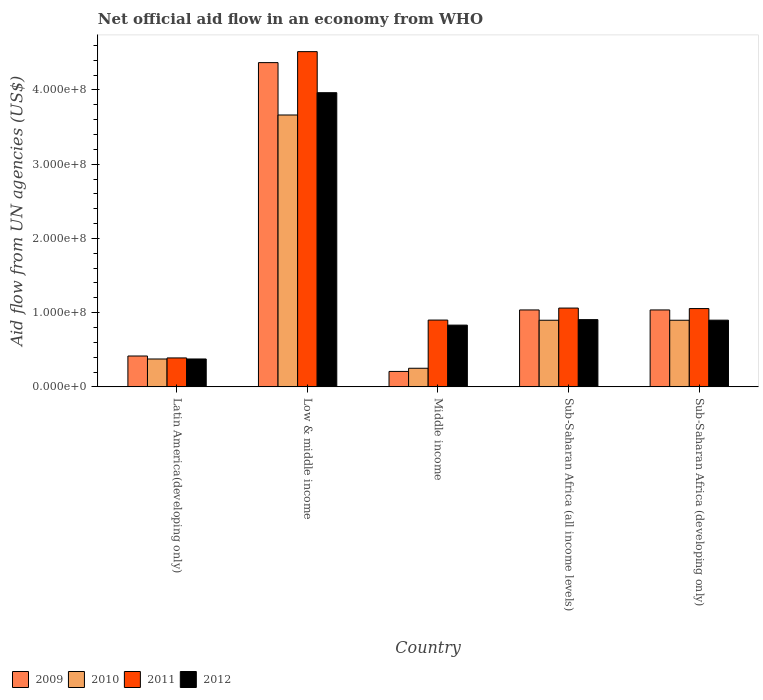How many different coloured bars are there?
Offer a terse response. 4. Are the number of bars per tick equal to the number of legend labels?
Make the answer very short. Yes. What is the label of the 5th group of bars from the left?
Give a very brief answer. Sub-Saharan Africa (developing only). What is the net official aid flow in 2009 in Middle income?
Your answer should be compact. 2.08e+07. Across all countries, what is the maximum net official aid flow in 2011?
Offer a terse response. 4.52e+08. Across all countries, what is the minimum net official aid flow in 2010?
Make the answer very short. 2.51e+07. In which country was the net official aid flow in 2011 maximum?
Give a very brief answer. Low & middle income. In which country was the net official aid flow in 2012 minimum?
Provide a succinct answer. Latin America(developing only). What is the total net official aid flow in 2010 in the graph?
Ensure brevity in your answer.  6.08e+08. What is the difference between the net official aid flow in 2012 in Latin America(developing only) and that in Low & middle income?
Provide a succinct answer. -3.59e+08. What is the difference between the net official aid flow in 2010 in Sub-Saharan Africa (developing only) and the net official aid flow in 2009 in Latin America(developing only)?
Your answer should be compact. 4.82e+07. What is the average net official aid flow in 2010 per country?
Make the answer very short. 1.22e+08. What is the difference between the net official aid flow of/in 2012 and net official aid flow of/in 2009 in Sub-Saharan Africa (developing only)?
Your response must be concise. -1.38e+07. In how many countries, is the net official aid flow in 2010 greater than 80000000 US$?
Your response must be concise. 3. What is the ratio of the net official aid flow in 2011 in Low & middle income to that in Sub-Saharan Africa (all income levels)?
Offer a very short reply. 4.25. Is the net official aid flow in 2012 in Latin America(developing only) less than that in Low & middle income?
Provide a short and direct response. Yes. Is the difference between the net official aid flow in 2012 in Latin America(developing only) and Low & middle income greater than the difference between the net official aid flow in 2009 in Latin America(developing only) and Low & middle income?
Ensure brevity in your answer.  Yes. What is the difference between the highest and the second highest net official aid flow in 2009?
Offer a terse response. 3.33e+08. What is the difference between the highest and the lowest net official aid flow in 2012?
Your response must be concise. 3.59e+08. Is it the case that in every country, the sum of the net official aid flow in 2011 and net official aid flow in 2012 is greater than the sum of net official aid flow in 2010 and net official aid flow in 2009?
Ensure brevity in your answer.  No. What does the 2nd bar from the left in Latin America(developing only) represents?
Your answer should be compact. 2010. Is it the case that in every country, the sum of the net official aid flow in 2010 and net official aid flow in 2011 is greater than the net official aid flow in 2009?
Offer a terse response. Yes. How many countries are there in the graph?
Provide a short and direct response. 5. Does the graph contain any zero values?
Provide a short and direct response. No. Does the graph contain grids?
Offer a very short reply. No. What is the title of the graph?
Give a very brief answer. Net official aid flow in an economy from WHO. Does "1988" appear as one of the legend labels in the graph?
Give a very brief answer. No. What is the label or title of the Y-axis?
Your answer should be compact. Aid flow from UN agencies (US$). What is the Aid flow from UN agencies (US$) of 2009 in Latin America(developing only)?
Provide a short and direct response. 4.16e+07. What is the Aid flow from UN agencies (US$) of 2010 in Latin America(developing only)?
Provide a short and direct response. 3.76e+07. What is the Aid flow from UN agencies (US$) of 2011 in Latin America(developing only)?
Your answer should be very brief. 3.90e+07. What is the Aid flow from UN agencies (US$) of 2012 in Latin America(developing only)?
Offer a terse response. 3.76e+07. What is the Aid flow from UN agencies (US$) of 2009 in Low & middle income?
Your answer should be compact. 4.37e+08. What is the Aid flow from UN agencies (US$) in 2010 in Low & middle income?
Offer a very short reply. 3.66e+08. What is the Aid flow from UN agencies (US$) in 2011 in Low & middle income?
Your response must be concise. 4.52e+08. What is the Aid flow from UN agencies (US$) of 2012 in Low & middle income?
Make the answer very short. 3.96e+08. What is the Aid flow from UN agencies (US$) in 2009 in Middle income?
Your answer should be very brief. 2.08e+07. What is the Aid flow from UN agencies (US$) in 2010 in Middle income?
Provide a succinct answer. 2.51e+07. What is the Aid flow from UN agencies (US$) in 2011 in Middle income?
Offer a terse response. 9.00e+07. What is the Aid flow from UN agencies (US$) in 2012 in Middle income?
Provide a short and direct response. 8.32e+07. What is the Aid flow from UN agencies (US$) of 2009 in Sub-Saharan Africa (all income levels)?
Make the answer very short. 1.04e+08. What is the Aid flow from UN agencies (US$) of 2010 in Sub-Saharan Africa (all income levels)?
Keep it short and to the point. 8.98e+07. What is the Aid flow from UN agencies (US$) of 2011 in Sub-Saharan Africa (all income levels)?
Ensure brevity in your answer.  1.06e+08. What is the Aid flow from UN agencies (US$) of 2012 in Sub-Saharan Africa (all income levels)?
Your response must be concise. 9.06e+07. What is the Aid flow from UN agencies (US$) of 2009 in Sub-Saharan Africa (developing only)?
Ensure brevity in your answer.  1.04e+08. What is the Aid flow from UN agencies (US$) in 2010 in Sub-Saharan Africa (developing only)?
Give a very brief answer. 8.98e+07. What is the Aid flow from UN agencies (US$) in 2011 in Sub-Saharan Africa (developing only)?
Give a very brief answer. 1.05e+08. What is the Aid flow from UN agencies (US$) of 2012 in Sub-Saharan Africa (developing only)?
Your response must be concise. 8.98e+07. Across all countries, what is the maximum Aid flow from UN agencies (US$) of 2009?
Make the answer very short. 4.37e+08. Across all countries, what is the maximum Aid flow from UN agencies (US$) of 2010?
Your response must be concise. 3.66e+08. Across all countries, what is the maximum Aid flow from UN agencies (US$) in 2011?
Keep it short and to the point. 4.52e+08. Across all countries, what is the maximum Aid flow from UN agencies (US$) of 2012?
Make the answer very short. 3.96e+08. Across all countries, what is the minimum Aid flow from UN agencies (US$) in 2009?
Your response must be concise. 2.08e+07. Across all countries, what is the minimum Aid flow from UN agencies (US$) of 2010?
Your answer should be very brief. 2.51e+07. Across all countries, what is the minimum Aid flow from UN agencies (US$) of 2011?
Your answer should be compact. 3.90e+07. Across all countries, what is the minimum Aid flow from UN agencies (US$) of 2012?
Your answer should be very brief. 3.76e+07. What is the total Aid flow from UN agencies (US$) in 2009 in the graph?
Provide a succinct answer. 7.06e+08. What is the total Aid flow from UN agencies (US$) in 2010 in the graph?
Your answer should be compact. 6.08e+08. What is the total Aid flow from UN agencies (US$) in 2011 in the graph?
Your answer should be very brief. 7.92e+08. What is the total Aid flow from UN agencies (US$) of 2012 in the graph?
Give a very brief answer. 6.97e+08. What is the difference between the Aid flow from UN agencies (US$) of 2009 in Latin America(developing only) and that in Low & middle income?
Provide a short and direct response. -3.95e+08. What is the difference between the Aid flow from UN agencies (US$) in 2010 in Latin America(developing only) and that in Low & middle income?
Your answer should be very brief. -3.29e+08. What is the difference between the Aid flow from UN agencies (US$) of 2011 in Latin America(developing only) and that in Low & middle income?
Make the answer very short. -4.13e+08. What is the difference between the Aid flow from UN agencies (US$) in 2012 in Latin America(developing only) and that in Low & middle income?
Give a very brief answer. -3.59e+08. What is the difference between the Aid flow from UN agencies (US$) in 2009 in Latin America(developing only) and that in Middle income?
Offer a terse response. 2.08e+07. What is the difference between the Aid flow from UN agencies (US$) in 2010 in Latin America(developing only) and that in Middle income?
Ensure brevity in your answer.  1.25e+07. What is the difference between the Aid flow from UN agencies (US$) in 2011 in Latin America(developing only) and that in Middle income?
Make the answer very short. -5.10e+07. What is the difference between the Aid flow from UN agencies (US$) of 2012 in Latin America(developing only) and that in Middle income?
Keep it short and to the point. -4.56e+07. What is the difference between the Aid flow from UN agencies (US$) in 2009 in Latin America(developing only) and that in Sub-Saharan Africa (all income levels)?
Make the answer very short. -6.20e+07. What is the difference between the Aid flow from UN agencies (US$) of 2010 in Latin America(developing only) and that in Sub-Saharan Africa (all income levels)?
Make the answer very short. -5.22e+07. What is the difference between the Aid flow from UN agencies (US$) in 2011 in Latin America(developing only) and that in Sub-Saharan Africa (all income levels)?
Provide a short and direct response. -6.72e+07. What is the difference between the Aid flow from UN agencies (US$) in 2012 in Latin America(developing only) and that in Sub-Saharan Africa (all income levels)?
Provide a succinct answer. -5.30e+07. What is the difference between the Aid flow from UN agencies (US$) in 2009 in Latin America(developing only) and that in Sub-Saharan Africa (developing only)?
Make the answer very short. -6.20e+07. What is the difference between the Aid flow from UN agencies (US$) of 2010 in Latin America(developing only) and that in Sub-Saharan Africa (developing only)?
Keep it short and to the point. -5.22e+07. What is the difference between the Aid flow from UN agencies (US$) in 2011 in Latin America(developing only) and that in Sub-Saharan Africa (developing only)?
Provide a short and direct response. -6.65e+07. What is the difference between the Aid flow from UN agencies (US$) of 2012 in Latin America(developing only) and that in Sub-Saharan Africa (developing only)?
Give a very brief answer. -5.23e+07. What is the difference between the Aid flow from UN agencies (US$) in 2009 in Low & middle income and that in Middle income?
Keep it short and to the point. 4.16e+08. What is the difference between the Aid flow from UN agencies (US$) in 2010 in Low & middle income and that in Middle income?
Offer a terse response. 3.41e+08. What is the difference between the Aid flow from UN agencies (US$) of 2011 in Low & middle income and that in Middle income?
Ensure brevity in your answer.  3.62e+08. What is the difference between the Aid flow from UN agencies (US$) of 2012 in Low & middle income and that in Middle income?
Your answer should be very brief. 3.13e+08. What is the difference between the Aid flow from UN agencies (US$) in 2009 in Low & middle income and that in Sub-Saharan Africa (all income levels)?
Make the answer very short. 3.33e+08. What is the difference between the Aid flow from UN agencies (US$) of 2010 in Low & middle income and that in Sub-Saharan Africa (all income levels)?
Keep it short and to the point. 2.76e+08. What is the difference between the Aid flow from UN agencies (US$) in 2011 in Low & middle income and that in Sub-Saharan Africa (all income levels)?
Ensure brevity in your answer.  3.45e+08. What is the difference between the Aid flow from UN agencies (US$) of 2012 in Low & middle income and that in Sub-Saharan Africa (all income levels)?
Make the answer very short. 3.06e+08. What is the difference between the Aid flow from UN agencies (US$) of 2009 in Low & middle income and that in Sub-Saharan Africa (developing only)?
Your response must be concise. 3.33e+08. What is the difference between the Aid flow from UN agencies (US$) in 2010 in Low & middle income and that in Sub-Saharan Africa (developing only)?
Ensure brevity in your answer.  2.76e+08. What is the difference between the Aid flow from UN agencies (US$) in 2011 in Low & middle income and that in Sub-Saharan Africa (developing only)?
Offer a terse response. 3.46e+08. What is the difference between the Aid flow from UN agencies (US$) of 2012 in Low & middle income and that in Sub-Saharan Africa (developing only)?
Provide a succinct answer. 3.06e+08. What is the difference between the Aid flow from UN agencies (US$) of 2009 in Middle income and that in Sub-Saharan Africa (all income levels)?
Give a very brief answer. -8.28e+07. What is the difference between the Aid flow from UN agencies (US$) in 2010 in Middle income and that in Sub-Saharan Africa (all income levels)?
Provide a succinct answer. -6.47e+07. What is the difference between the Aid flow from UN agencies (US$) of 2011 in Middle income and that in Sub-Saharan Africa (all income levels)?
Keep it short and to the point. -1.62e+07. What is the difference between the Aid flow from UN agencies (US$) in 2012 in Middle income and that in Sub-Saharan Africa (all income levels)?
Make the answer very short. -7.39e+06. What is the difference between the Aid flow from UN agencies (US$) in 2009 in Middle income and that in Sub-Saharan Africa (developing only)?
Offer a very short reply. -8.28e+07. What is the difference between the Aid flow from UN agencies (US$) of 2010 in Middle income and that in Sub-Saharan Africa (developing only)?
Your response must be concise. -6.47e+07. What is the difference between the Aid flow from UN agencies (US$) in 2011 in Middle income and that in Sub-Saharan Africa (developing only)?
Offer a terse response. -1.55e+07. What is the difference between the Aid flow from UN agencies (US$) of 2012 in Middle income and that in Sub-Saharan Africa (developing only)?
Provide a succinct answer. -6.67e+06. What is the difference between the Aid flow from UN agencies (US$) of 2011 in Sub-Saharan Africa (all income levels) and that in Sub-Saharan Africa (developing only)?
Offer a very short reply. 6.70e+05. What is the difference between the Aid flow from UN agencies (US$) of 2012 in Sub-Saharan Africa (all income levels) and that in Sub-Saharan Africa (developing only)?
Keep it short and to the point. 7.20e+05. What is the difference between the Aid flow from UN agencies (US$) in 2009 in Latin America(developing only) and the Aid flow from UN agencies (US$) in 2010 in Low & middle income?
Provide a succinct answer. -3.25e+08. What is the difference between the Aid flow from UN agencies (US$) in 2009 in Latin America(developing only) and the Aid flow from UN agencies (US$) in 2011 in Low & middle income?
Ensure brevity in your answer.  -4.10e+08. What is the difference between the Aid flow from UN agencies (US$) of 2009 in Latin America(developing only) and the Aid flow from UN agencies (US$) of 2012 in Low & middle income?
Offer a terse response. -3.55e+08. What is the difference between the Aid flow from UN agencies (US$) of 2010 in Latin America(developing only) and the Aid flow from UN agencies (US$) of 2011 in Low & middle income?
Provide a succinct answer. -4.14e+08. What is the difference between the Aid flow from UN agencies (US$) of 2010 in Latin America(developing only) and the Aid flow from UN agencies (US$) of 2012 in Low & middle income?
Give a very brief answer. -3.59e+08. What is the difference between the Aid flow from UN agencies (US$) of 2011 in Latin America(developing only) and the Aid flow from UN agencies (US$) of 2012 in Low & middle income?
Ensure brevity in your answer.  -3.57e+08. What is the difference between the Aid flow from UN agencies (US$) of 2009 in Latin America(developing only) and the Aid flow from UN agencies (US$) of 2010 in Middle income?
Ensure brevity in your answer.  1.65e+07. What is the difference between the Aid flow from UN agencies (US$) in 2009 in Latin America(developing only) and the Aid flow from UN agencies (US$) in 2011 in Middle income?
Offer a terse response. -4.84e+07. What is the difference between the Aid flow from UN agencies (US$) of 2009 in Latin America(developing only) and the Aid flow from UN agencies (US$) of 2012 in Middle income?
Your answer should be very brief. -4.16e+07. What is the difference between the Aid flow from UN agencies (US$) in 2010 in Latin America(developing only) and the Aid flow from UN agencies (US$) in 2011 in Middle income?
Keep it short and to the point. -5.24e+07. What is the difference between the Aid flow from UN agencies (US$) in 2010 in Latin America(developing only) and the Aid flow from UN agencies (US$) in 2012 in Middle income?
Your answer should be very brief. -4.56e+07. What is the difference between the Aid flow from UN agencies (US$) of 2011 in Latin America(developing only) and the Aid flow from UN agencies (US$) of 2012 in Middle income?
Your answer should be compact. -4.42e+07. What is the difference between the Aid flow from UN agencies (US$) of 2009 in Latin America(developing only) and the Aid flow from UN agencies (US$) of 2010 in Sub-Saharan Africa (all income levels)?
Offer a terse response. -4.82e+07. What is the difference between the Aid flow from UN agencies (US$) of 2009 in Latin America(developing only) and the Aid flow from UN agencies (US$) of 2011 in Sub-Saharan Africa (all income levels)?
Offer a very short reply. -6.46e+07. What is the difference between the Aid flow from UN agencies (US$) in 2009 in Latin America(developing only) and the Aid flow from UN agencies (US$) in 2012 in Sub-Saharan Africa (all income levels)?
Your answer should be very brief. -4.90e+07. What is the difference between the Aid flow from UN agencies (US$) of 2010 in Latin America(developing only) and the Aid flow from UN agencies (US$) of 2011 in Sub-Saharan Africa (all income levels)?
Your answer should be compact. -6.86e+07. What is the difference between the Aid flow from UN agencies (US$) of 2010 in Latin America(developing only) and the Aid flow from UN agencies (US$) of 2012 in Sub-Saharan Africa (all income levels)?
Offer a very short reply. -5.30e+07. What is the difference between the Aid flow from UN agencies (US$) of 2011 in Latin America(developing only) and the Aid flow from UN agencies (US$) of 2012 in Sub-Saharan Africa (all income levels)?
Your response must be concise. -5.16e+07. What is the difference between the Aid flow from UN agencies (US$) of 2009 in Latin America(developing only) and the Aid flow from UN agencies (US$) of 2010 in Sub-Saharan Africa (developing only)?
Give a very brief answer. -4.82e+07. What is the difference between the Aid flow from UN agencies (US$) of 2009 in Latin America(developing only) and the Aid flow from UN agencies (US$) of 2011 in Sub-Saharan Africa (developing only)?
Give a very brief answer. -6.39e+07. What is the difference between the Aid flow from UN agencies (US$) in 2009 in Latin America(developing only) and the Aid flow from UN agencies (US$) in 2012 in Sub-Saharan Africa (developing only)?
Keep it short and to the point. -4.83e+07. What is the difference between the Aid flow from UN agencies (US$) of 2010 in Latin America(developing only) and the Aid flow from UN agencies (US$) of 2011 in Sub-Saharan Africa (developing only)?
Your answer should be compact. -6.79e+07. What is the difference between the Aid flow from UN agencies (US$) of 2010 in Latin America(developing only) and the Aid flow from UN agencies (US$) of 2012 in Sub-Saharan Africa (developing only)?
Offer a very short reply. -5.23e+07. What is the difference between the Aid flow from UN agencies (US$) in 2011 in Latin America(developing only) and the Aid flow from UN agencies (US$) in 2012 in Sub-Saharan Africa (developing only)?
Provide a short and direct response. -5.09e+07. What is the difference between the Aid flow from UN agencies (US$) of 2009 in Low & middle income and the Aid flow from UN agencies (US$) of 2010 in Middle income?
Offer a terse response. 4.12e+08. What is the difference between the Aid flow from UN agencies (US$) in 2009 in Low & middle income and the Aid flow from UN agencies (US$) in 2011 in Middle income?
Offer a very short reply. 3.47e+08. What is the difference between the Aid flow from UN agencies (US$) in 2009 in Low & middle income and the Aid flow from UN agencies (US$) in 2012 in Middle income?
Give a very brief answer. 3.54e+08. What is the difference between the Aid flow from UN agencies (US$) of 2010 in Low & middle income and the Aid flow from UN agencies (US$) of 2011 in Middle income?
Offer a terse response. 2.76e+08. What is the difference between the Aid flow from UN agencies (US$) of 2010 in Low & middle income and the Aid flow from UN agencies (US$) of 2012 in Middle income?
Your answer should be compact. 2.83e+08. What is the difference between the Aid flow from UN agencies (US$) of 2011 in Low & middle income and the Aid flow from UN agencies (US$) of 2012 in Middle income?
Offer a very short reply. 3.68e+08. What is the difference between the Aid flow from UN agencies (US$) of 2009 in Low & middle income and the Aid flow from UN agencies (US$) of 2010 in Sub-Saharan Africa (all income levels)?
Your answer should be very brief. 3.47e+08. What is the difference between the Aid flow from UN agencies (US$) of 2009 in Low & middle income and the Aid flow from UN agencies (US$) of 2011 in Sub-Saharan Africa (all income levels)?
Ensure brevity in your answer.  3.31e+08. What is the difference between the Aid flow from UN agencies (US$) in 2009 in Low & middle income and the Aid flow from UN agencies (US$) in 2012 in Sub-Saharan Africa (all income levels)?
Make the answer very short. 3.46e+08. What is the difference between the Aid flow from UN agencies (US$) in 2010 in Low & middle income and the Aid flow from UN agencies (US$) in 2011 in Sub-Saharan Africa (all income levels)?
Offer a terse response. 2.60e+08. What is the difference between the Aid flow from UN agencies (US$) of 2010 in Low & middle income and the Aid flow from UN agencies (US$) of 2012 in Sub-Saharan Africa (all income levels)?
Your answer should be compact. 2.76e+08. What is the difference between the Aid flow from UN agencies (US$) of 2011 in Low & middle income and the Aid flow from UN agencies (US$) of 2012 in Sub-Saharan Africa (all income levels)?
Provide a succinct answer. 3.61e+08. What is the difference between the Aid flow from UN agencies (US$) of 2009 in Low & middle income and the Aid flow from UN agencies (US$) of 2010 in Sub-Saharan Africa (developing only)?
Ensure brevity in your answer.  3.47e+08. What is the difference between the Aid flow from UN agencies (US$) of 2009 in Low & middle income and the Aid flow from UN agencies (US$) of 2011 in Sub-Saharan Africa (developing only)?
Your answer should be compact. 3.31e+08. What is the difference between the Aid flow from UN agencies (US$) of 2009 in Low & middle income and the Aid flow from UN agencies (US$) of 2012 in Sub-Saharan Africa (developing only)?
Keep it short and to the point. 3.47e+08. What is the difference between the Aid flow from UN agencies (US$) of 2010 in Low & middle income and the Aid flow from UN agencies (US$) of 2011 in Sub-Saharan Africa (developing only)?
Your answer should be very brief. 2.61e+08. What is the difference between the Aid flow from UN agencies (US$) in 2010 in Low & middle income and the Aid flow from UN agencies (US$) in 2012 in Sub-Saharan Africa (developing only)?
Ensure brevity in your answer.  2.76e+08. What is the difference between the Aid flow from UN agencies (US$) of 2011 in Low & middle income and the Aid flow from UN agencies (US$) of 2012 in Sub-Saharan Africa (developing only)?
Your answer should be very brief. 3.62e+08. What is the difference between the Aid flow from UN agencies (US$) of 2009 in Middle income and the Aid flow from UN agencies (US$) of 2010 in Sub-Saharan Africa (all income levels)?
Provide a succinct answer. -6.90e+07. What is the difference between the Aid flow from UN agencies (US$) in 2009 in Middle income and the Aid flow from UN agencies (US$) in 2011 in Sub-Saharan Africa (all income levels)?
Give a very brief answer. -8.54e+07. What is the difference between the Aid flow from UN agencies (US$) in 2009 in Middle income and the Aid flow from UN agencies (US$) in 2012 in Sub-Saharan Africa (all income levels)?
Keep it short and to the point. -6.98e+07. What is the difference between the Aid flow from UN agencies (US$) of 2010 in Middle income and the Aid flow from UN agencies (US$) of 2011 in Sub-Saharan Africa (all income levels)?
Your response must be concise. -8.11e+07. What is the difference between the Aid flow from UN agencies (US$) of 2010 in Middle income and the Aid flow from UN agencies (US$) of 2012 in Sub-Saharan Africa (all income levels)?
Your answer should be compact. -6.55e+07. What is the difference between the Aid flow from UN agencies (US$) in 2011 in Middle income and the Aid flow from UN agencies (US$) in 2012 in Sub-Saharan Africa (all income levels)?
Your response must be concise. -5.90e+05. What is the difference between the Aid flow from UN agencies (US$) in 2009 in Middle income and the Aid flow from UN agencies (US$) in 2010 in Sub-Saharan Africa (developing only)?
Your answer should be compact. -6.90e+07. What is the difference between the Aid flow from UN agencies (US$) of 2009 in Middle income and the Aid flow from UN agencies (US$) of 2011 in Sub-Saharan Africa (developing only)?
Make the answer very short. -8.47e+07. What is the difference between the Aid flow from UN agencies (US$) of 2009 in Middle income and the Aid flow from UN agencies (US$) of 2012 in Sub-Saharan Africa (developing only)?
Give a very brief answer. -6.90e+07. What is the difference between the Aid flow from UN agencies (US$) of 2010 in Middle income and the Aid flow from UN agencies (US$) of 2011 in Sub-Saharan Africa (developing only)?
Your answer should be very brief. -8.04e+07. What is the difference between the Aid flow from UN agencies (US$) of 2010 in Middle income and the Aid flow from UN agencies (US$) of 2012 in Sub-Saharan Africa (developing only)?
Provide a succinct answer. -6.48e+07. What is the difference between the Aid flow from UN agencies (US$) of 2009 in Sub-Saharan Africa (all income levels) and the Aid flow from UN agencies (US$) of 2010 in Sub-Saharan Africa (developing only)?
Your answer should be very brief. 1.39e+07. What is the difference between the Aid flow from UN agencies (US$) of 2009 in Sub-Saharan Africa (all income levels) and the Aid flow from UN agencies (US$) of 2011 in Sub-Saharan Africa (developing only)?
Your answer should be very brief. -1.86e+06. What is the difference between the Aid flow from UN agencies (US$) of 2009 in Sub-Saharan Africa (all income levels) and the Aid flow from UN agencies (US$) of 2012 in Sub-Saharan Africa (developing only)?
Offer a very short reply. 1.38e+07. What is the difference between the Aid flow from UN agencies (US$) of 2010 in Sub-Saharan Africa (all income levels) and the Aid flow from UN agencies (US$) of 2011 in Sub-Saharan Africa (developing only)?
Provide a short and direct response. -1.57e+07. What is the difference between the Aid flow from UN agencies (US$) in 2011 in Sub-Saharan Africa (all income levels) and the Aid flow from UN agencies (US$) in 2012 in Sub-Saharan Africa (developing only)?
Your answer should be very brief. 1.63e+07. What is the average Aid flow from UN agencies (US$) in 2009 per country?
Provide a short and direct response. 1.41e+08. What is the average Aid flow from UN agencies (US$) in 2010 per country?
Keep it short and to the point. 1.22e+08. What is the average Aid flow from UN agencies (US$) of 2011 per country?
Offer a terse response. 1.58e+08. What is the average Aid flow from UN agencies (US$) of 2012 per country?
Offer a very short reply. 1.39e+08. What is the difference between the Aid flow from UN agencies (US$) in 2009 and Aid flow from UN agencies (US$) in 2010 in Latin America(developing only)?
Offer a very short reply. 4.01e+06. What is the difference between the Aid flow from UN agencies (US$) of 2009 and Aid flow from UN agencies (US$) of 2011 in Latin America(developing only)?
Your answer should be very brief. 2.59e+06. What is the difference between the Aid flow from UN agencies (US$) in 2009 and Aid flow from UN agencies (US$) in 2012 in Latin America(developing only)?
Offer a terse response. 3.99e+06. What is the difference between the Aid flow from UN agencies (US$) in 2010 and Aid flow from UN agencies (US$) in 2011 in Latin America(developing only)?
Ensure brevity in your answer.  -1.42e+06. What is the difference between the Aid flow from UN agencies (US$) of 2010 and Aid flow from UN agencies (US$) of 2012 in Latin America(developing only)?
Offer a terse response. -2.00e+04. What is the difference between the Aid flow from UN agencies (US$) of 2011 and Aid flow from UN agencies (US$) of 2012 in Latin America(developing only)?
Ensure brevity in your answer.  1.40e+06. What is the difference between the Aid flow from UN agencies (US$) of 2009 and Aid flow from UN agencies (US$) of 2010 in Low & middle income?
Your answer should be compact. 7.06e+07. What is the difference between the Aid flow from UN agencies (US$) in 2009 and Aid flow from UN agencies (US$) in 2011 in Low & middle income?
Keep it short and to the point. -1.48e+07. What is the difference between the Aid flow from UN agencies (US$) of 2009 and Aid flow from UN agencies (US$) of 2012 in Low & middle income?
Keep it short and to the point. 4.05e+07. What is the difference between the Aid flow from UN agencies (US$) in 2010 and Aid flow from UN agencies (US$) in 2011 in Low & middle income?
Offer a terse response. -8.54e+07. What is the difference between the Aid flow from UN agencies (US$) of 2010 and Aid flow from UN agencies (US$) of 2012 in Low & middle income?
Keep it short and to the point. -3.00e+07. What is the difference between the Aid flow from UN agencies (US$) of 2011 and Aid flow from UN agencies (US$) of 2012 in Low & middle income?
Provide a short and direct response. 5.53e+07. What is the difference between the Aid flow from UN agencies (US$) in 2009 and Aid flow from UN agencies (US$) in 2010 in Middle income?
Make the answer very short. -4.27e+06. What is the difference between the Aid flow from UN agencies (US$) in 2009 and Aid flow from UN agencies (US$) in 2011 in Middle income?
Provide a succinct answer. -6.92e+07. What is the difference between the Aid flow from UN agencies (US$) in 2009 and Aid flow from UN agencies (US$) in 2012 in Middle income?
Keep it short and to the point. -6.24e+07. What is the difference between the Aid flow from UN agencies (US$) in 2010 and Aid flow from UN agencies (US$) in 2011 in Middle income?
Your answer should be very brief. -6.49e+07. What is the difference between the Aid flow from UN agencies (US$) in 2010 and Aid flow from UN agencies (US$) in 2012 in Middle income?
Provide a succinct answer. -5.81e+07. What is the difference between the Aid flow from UN agencies (US$) of 2011 and Aid flow from UN agencies (US$) of 2012 in Middle income?
Offer a terse response. 6.80e+06. What is the difference between the Aid flow from UN agencies (US$) of 2009 and Aid flow from UN agencies (US$) of 2010 in Sub-Saharan Africa (all income levels)?
Keep it short and to the point. 1.39e+07. What is the difference between the Aid flow from UN agencies (US$) of 2009 and Aid flow from UN agencies (US$) of 2011 in Sub-Saharan Africa (all income levels)?
Your answer should be very brief. -2.53e+06. What is the difference between the Aid flow from UN agencies (US$) of 2009 and Aid flow from UN agencies (US$) of 2012 in Sub-Saharan Africa (all income levels)?
Provide a short and direct response. 1.30e+07. What is the difference between the Aid flow from UN agencies (US$) of 2010 and Aid flow from UN agencies (US$) of 2011 in Sub-Saharan Africa (all income levels)?
Your answer should be compact. -1.64e+07. What is the difference between the Aid flow from UN agencies (US$) in 2010 and Aid flow from UN agencies (US$) in 2012 in Sub-Saharan Africa (all income levels)?
Give a very brief answer. -8.10e+05. What is the difference between the Aid flow from UN agencies (US$) of 2011 and Aid flow from UN agencies (US$) of 2012 in Sub-Saharan Africa (all income levels)?
Your answer should be very brief. 1.56e+07. What is the difference between the Aid flow from UN agencies (US$) of 2009 and Aid flow from UN agencies (US$) of 2010 in Sub-Saharan Africa (developing only)?
Provide a succinct answer. 1.39e+07. What is the difference between the Aid flow from UN agencies (US$) of 2009 and Aid flow from UN agencies (US$) of 2011 in Sub-Saharan Africa (developing only)?
Make the answer very short. -1.86e+06. What is the difference between the Aid flow from UN agencies (US$) in 2009 and Aid flow from UN agencies (US$) in 2012 in Sub-Saharan Africa (developing only)?
Offer a terse response. 1.38e+07. What is the difference between the Aid flow from UN agencies (US$) of 2010 and Aid flow from UN agencies (US$) of 2011 in Sub-Saharan Africa (developing only)?
Keep it short and to the point. -1.57e+07. What is the difference between the Aid flow from UN agencies (US$) of 2010 and Aid flow from UN agencies (US$) of 2012 in Sub-Saharan Africa (developing only)?
Provide a short and direct response. -9.00e+04. What is the difference between the Aid flow from UN agencies (US$) in 2011 and Aid flow from UN agencies (US$) in 2012 in Sub-Saharan Africa (developing only)?
Provide a short and direct response. 1.56e+07. What is the ratio of the Aid flow from UN agencies (US$) in 2009 in Latin America(developing only) to that in Low & middle income?
Give a very brief answer. 0.1. What is the ratio of the Aid flow from UN agencies (US$) in 2010 in Latin America(developing only) to that in Low & middle income?
Your response must be concise. 0.1. What is the ratio of the Aid flow from UN agencies (US$) of 2011 in Latin America(developing only) to that in Low & middle income?
Provide a succinct answer. 0.09. What is the ratio of the Aid flow from UN agencies (US$) of 2012 in Latin America(developing only) to that in Low & middle income?
Keep it short and to the point. 0.09. What is the ratio of the Aid flow from UN agencies (US$) of 2009 in Latin America(developing only) to that in Middle income?
Provide a short and direct response. 2. What is the ratio of the Aid flow from UN agencies (US$) of 2010 in Latin America(developing only) to that in Middle income?
Offer a very short reply. 1.5. What is the ratio of the Aid flow from UN agencies (US$) in 2011 in Latin America(developing only) to that in Middle income?
Ensure brevity in your answer.  0.43. What is the ratio of the Aid flow from UN agencies (US$) in 2012 in Latin America(developing only) to that in Middle income?
Your answer should be compact. 0.45. What is the ratio of the Aid flow from UN agencies (US$) in 2009 in Latin America(developing only) to that in Sub-Saharan Africa (all income levels)?
Your answer should be compact. 0.4. What is the ratio of the Aid flow from UN agencies (US$) in 2010 in Latin America(developing only) to that in Sub-Saharan Africa (all income levels)?
Offer a very short reply. 0.42. What is the ratio of the Aid flow from UN agencies (US$) of 2011 in Latin America(developing only) to that in Sub-Saharan Africa (all income levels)?
Offer a very short reply. 0.37. What is the ratio of the Aid flow from UN agencies (US$) in 2012 in Latin America(developing only) to that in Sub-Saharan Africa (all income levels)?
Offer a very short reply. 0.41. What is the ratio of the Aid flow from UN agencies (US$) in 2009 in Latin America(developing only) to that in Sub-Saharan Africa (developing only)?
Your answer should be very brief. 0.4. What is the ratio of the Aid flow from UN agencies (US$) in 2010 in Latin America(developing only) to that in Sub-Saharan Africa (developing only)?
Offer a very short reply. 0.42. What is the ratio of the Aid flow from UN agencies (US$) of 2011 in Latin America(developing only) to that in Sub-Saharan Africa (developing only)?
Give a very brief answer. 0.37. What is the ratio of the Aid flow from UN agencies (US$) of 2012 in Latin America(developing only) to that in Sub-Saharan Africa (developing only)?
Provide a succinct answer. 0.42. What is the ratio of the Aid flow from UN agencies (US$) of 2009 in Low & middle income to that in Middle income?
Your response must be concise. 21. What is the ratio of the Aid flow from UN agencies (US$) in 2010 in Low & middle income to that in Middle income?
Provide a succinct answer. 14.61. What is the ratio of the Aid flow from UN agencies (US$) of 2011 in Low & middle income to that in Middle income?
Offer a terse response. 5.02. What is the ratio of the Aid flow from UN agencies (US$) of 2012 in Low & middle income to that in Middle income?
Provide a short and direct response. 4.76. What is the ratio of the Aid flow from UN agencies (US$) in 2009 in Low & middle income to that in Sub-Saharan Africa (all income levels)?
Give a very brief answer. 4.22. What is the ratio of the Aid flow from UN agencies (US$) in 2010 in Low & middle income to that in Sub-Saharan Africa (all income levels)?
Ensure brevity in your answer.  4.08. What is the ratio of the Aid flow from UN agencies (US$) in 2011 in Low & middle income to that in Sub-Saharan Africa (all income levels)?
Your answer should be compact. 4.25. What is the ratio of the Aid flow from UN agencies (US$) of 2012 in Low & middle income to that in Sub-Saharan Africa (all income levels)?
Your answer should be compact. 4.38. What is the ratio of the Aid flow from UN agencies (US$) in 2009 in Low & middle income to that in Sub-Saharan Africa (developing only)?
Give a very brief answer. 4.22. What is the ratio of the Aid flow from UN agencies (US$) of 2010 in Low & middle income to that in Sub-Saharan Africa (developing only)?
Offer a terse response. 4.08. What is the ratio of the Aid flow from UN agencies (US$) in 2011 in Low & middle income to that in Sub-Saharan Africa (developing only)?
Ensure brevity in your answer.  4.28. What is the ratio of the Aid flow from UN agencies (US$) in 2012 in Low & middle income to that in Sub-Saharan Africa (developing only)?
Offer a terse response. 4.41. What is the ratio of the Aid flow from UN agencies (US$) in 2009 in Middle income to that in Sub-Saharan Africa (all income levels)?
Offer a very short reply. 0.2. What is the ratio of the Aid flow from UN agencies (US$) of 2010 in Middle income to that in Sub-Saharan Africa (all income levels)?
Provide a succinct answer. 0.28. What is the ratio of the Aid flow from UN agencies (US$) of 2011 in Middle income to that in Sub-Saharan Africa (all income levels)?
Offer a very short reply. 0.85. What is the ratio of the Aid flow from UN agencies (US$) of 2012 in Middle income to that in Sub-Saharan Africa (all income levels)?
Give a very brief answer. 0.92. What is the ratio of the Aid flow from UN agencies (US$) in 2009 in Middle income to that in Sub-Saharan Africa (developing only)?
Make the answer very short. 0.2. What is the ratio of the Aid flow from UN agencies (US$) in 2010 in Middle income to that in Sub-Saharan Africa (developing only)?
Your answer should be compact. 0.28. What is the ratio of the Aid flow from UN agencies (US$) in 2011 in Middle income to that in Sub-Saharan Africa (developing only)?
Your answer should be compact. 0.85. What is the ratio of the Aid flow from UN agencies (US$) in 2012 in Middle income to that in Sub-Saharan Africa (developing only)?
Give a very brief answer. 0.93. What is the ratio of the Aid flow from UN agencies (US$) of 2011 in Sub-Saharan Africa (all income levels) to that in Sub-Saharan Africa (developing only)?
Give a very brief answer. 1.01. What is the ratio of the Aid flow from UN agencies (US$) of 2012 in Sub-Saharan Africa (all income levels) to that in Sub-Saharan Africa (developing only)?
Give a very brief answer. 1.01. What is the difference between the highest and the second highest Aid flow from UN agencies (US$) in 2009?
Your response must be concise. 3.33e+08. What is the difference between the highest and the second highest Aid flow from UN agencies (US$) of 2010?
Ensure brevity in your answer.  2.76e+08. What is the difference between the highest and the second highest Aid flow from UN agencies (US$) in 2011?
Provide a succinct answer. 3.45e+08. What is the difference between the highest and the second highest Aid flow from UN agencies (US$) in 2012?
Make the answer very short. 3.06e+08. What is the difference between the highest and the lowest Aid flow from UN agencies (US$) in 2009?
Your response must be concise. 4.16e+08. What is the difference between the highest and the lowest Aid flow from UN agencies (US$) in 2010?
Ensure brevity in your answer.  3.41e+08. What is the difference between the highest and the lowest Aid flow from UN agencies (US$) of 2011?
Ensure brevity in your answer.  4.13e+08. What is the difference between the highest and the lowest Aid flow from UN agencies (US$) in 2012?
Your answer should be compact. 3.59e+08. 